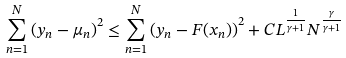<formula> <loc_0><loc_0><loc_500><loc_500>\sum _ { n = 1 } ^ { N } \left ( y _ { n } - \mu _ { n } \right ) ^ { 2 } \leq \sum _ { n = 1 } ^ { N } \left ( y _ { n } - F ( x _ { n } ) \right ) ^ { 2 } + C L ^ { \frac { 1 } { \gamma + 1 } } N ^ { \frac { \gamma } { \gamma + 1 } }</formula> 